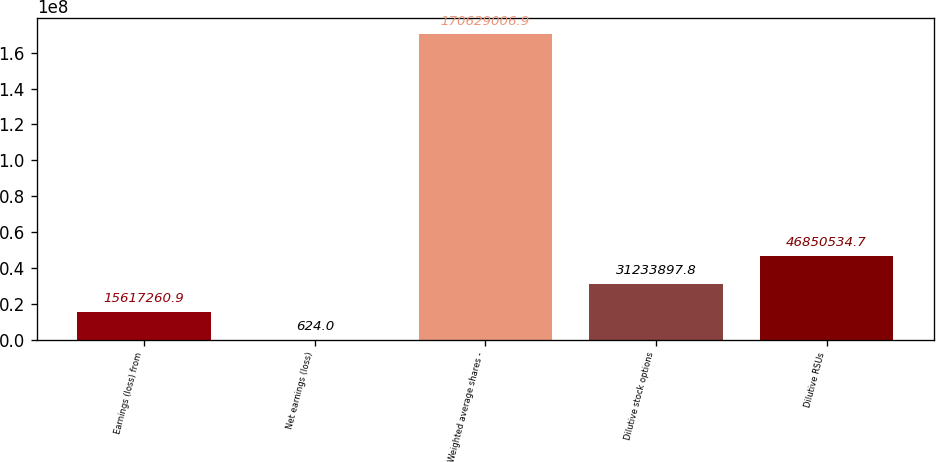<chart> <loc_0><loc_0><loc_500><loc_500><bar_chart><fcel>Earnings (loss) from<fcel>Net earnings (loss)<fcel>Weighted average shares -<fcel>Dilutive stock options<fcel>Dilutive RSUs<nl><fcel>1.56173e+07<fcel>624<fcel>1.70629e+08<fcel>3.12339e+07<fcel>4.68505e+07<nl></chart> 